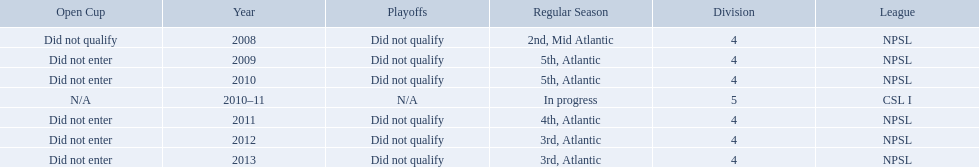What are the names of the leagues? NPSL, CSL I. Which league other than npsl did ny soccer team play under? CSL I. 